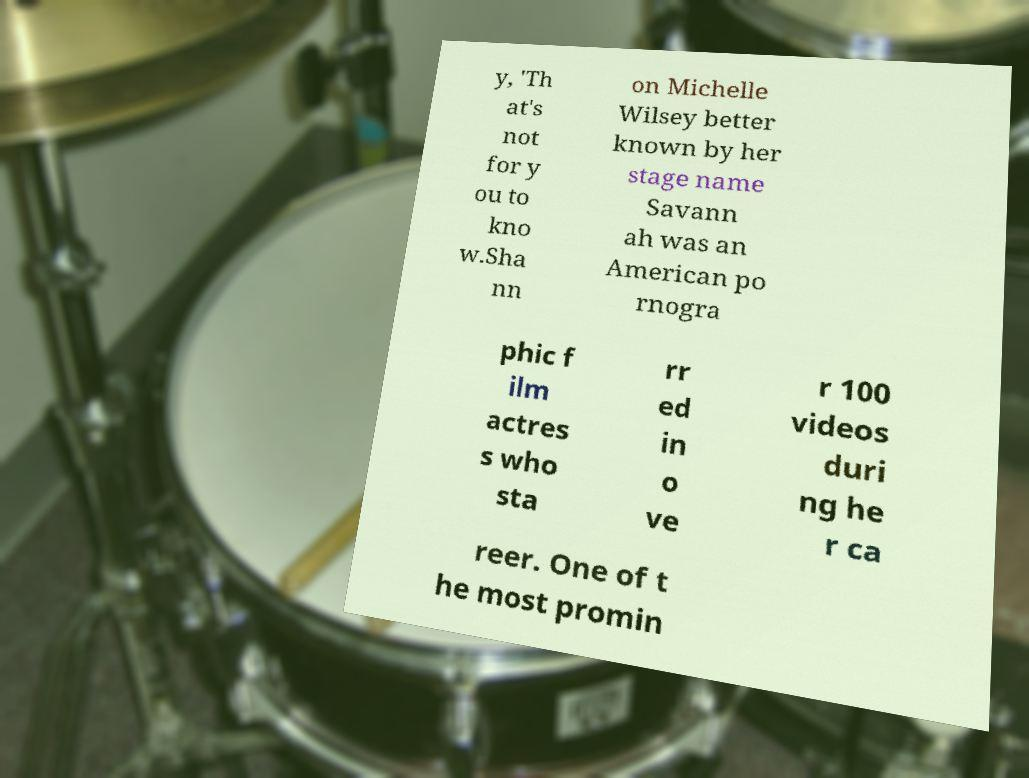There's text embedded in this image that I need extracted. Can you transcribe it verbatim? y, 'Th at's not for y ou to kno w.Sha nn on Michelle Wilsey better known by her stage name Savann ah was an American po rnogra phic f ilm actres s who sta rr ed in o ve r 100 videos duri ng he r ca reer. One of t he most promin 